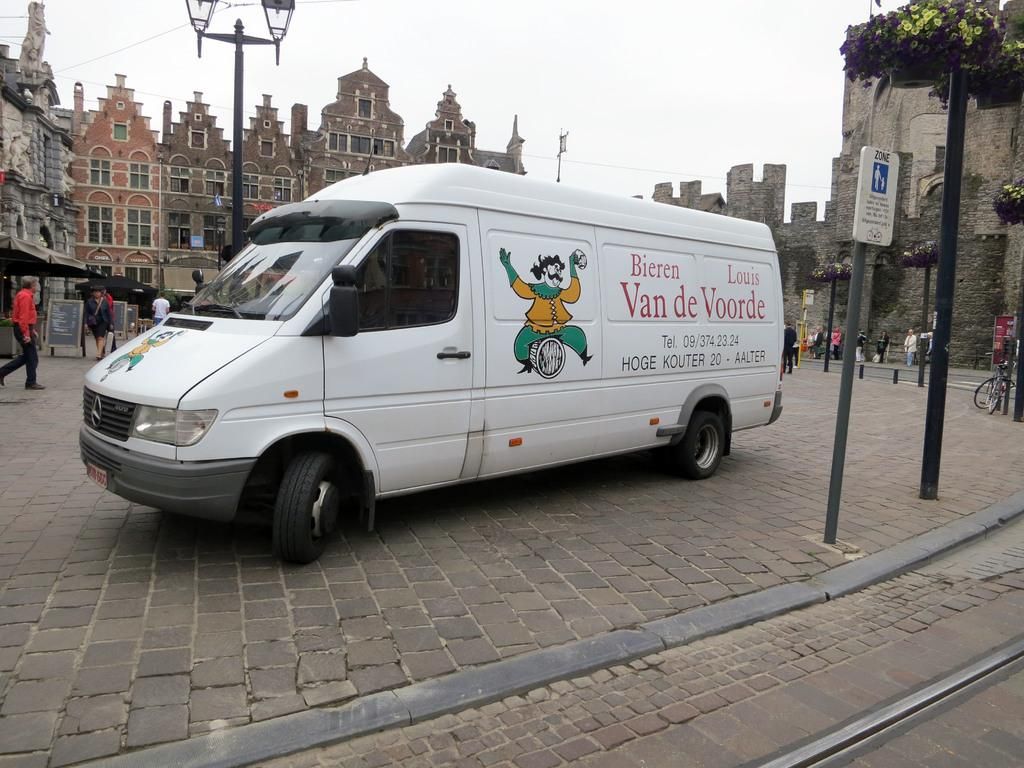Provide a one-sentence caption for the provided image. a Bieren Louis Van de Voorde parked on a cobblestone road. 